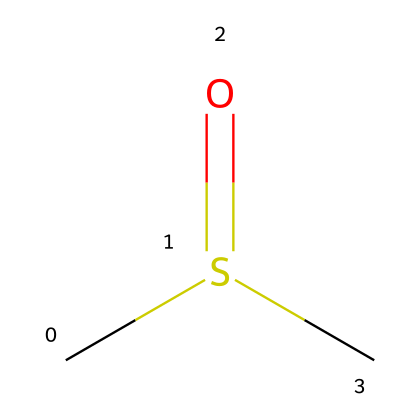What is the chemical name of the compound represented by the SMILES? The SMILES representation "CS(=O)C" corresponds to a compound where a sulfur atom is bonded to two methyl groups (C) and has a double bond with an oxygen (O). This structure identifies it as dimethyl sulfoxide.
Answer: dimethyl sulfoxide How many carbon atoms are present in the molecule? Upon examining the structure, the SMILES indicates two methyl groups (C) attached to the sulfur atom, meaning there are two carbon atoms in total.
Answer: 2 What type of bond exists between the sulfur and oxygen atoms? The "S(=O)" part of the SMILES indicates a double bond between the sulfur (S) and oxygen (O) atoms. The equal sign ('=') shows the nature of the bond as a double bond.
Answer: double bond What functional group is present in dimethyl sulfoxide? The presence of sulfur and oxygen, specifically the structure "S(=O)", indicates that this compound contains a sulfoxide functional group, characterized by a sulfur atom bonded to an oxygen atom via a double bond.
Answer: sulfoxide How many total atoms are in the chemical structure? The structure represents 2 carbon atoms, 1 sulfur atom, and 1 oxygen atom, totaling 4 atoms in the compound. This is calculated by simply counting each type of atom present in the SMILES.
Answer: 4 Does this compound contain any hydrogen atoms? Each methyl group (C) in the structure normally contributes three hydrogen atoms, so with two methyl groups, there are a total of 6 hydrogen atoms present.
Answer: yes 